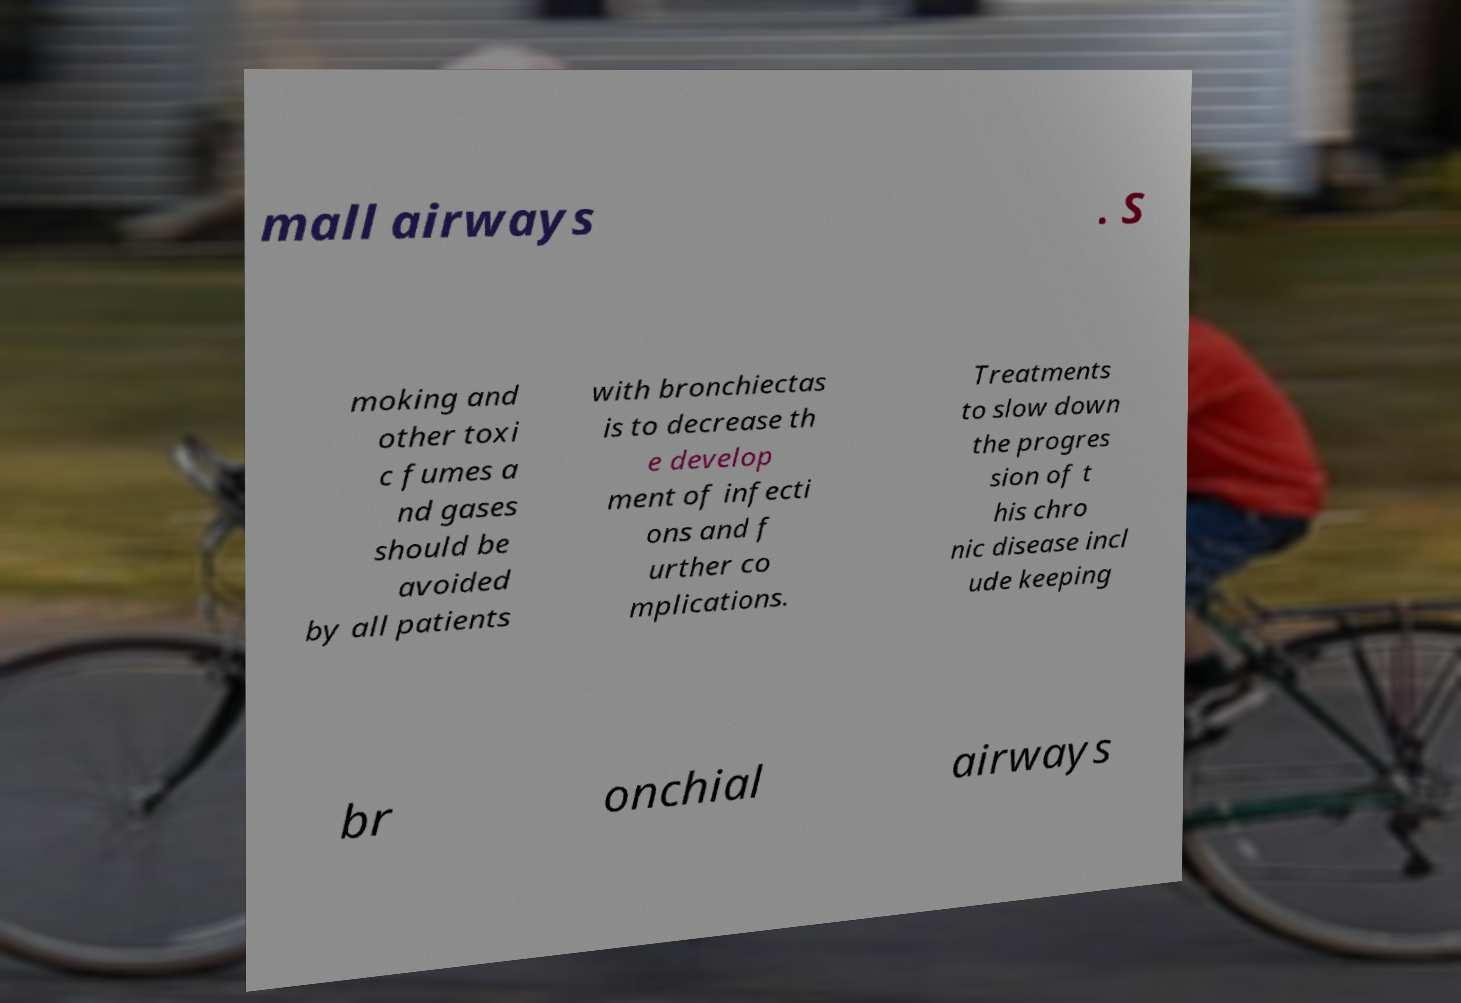There's text embedded in this image that I need extracted. Can you transcribe it verbatim? mall airways . S moking and other toxi c fumes a nd gases should be avoided by all patients with bronchiectas is to decrease th e develop ment of infecti ons and f urther co mplications. Treatments to slow down the progres sion of t his chro nic disease incl ude keeping br onchial airways 